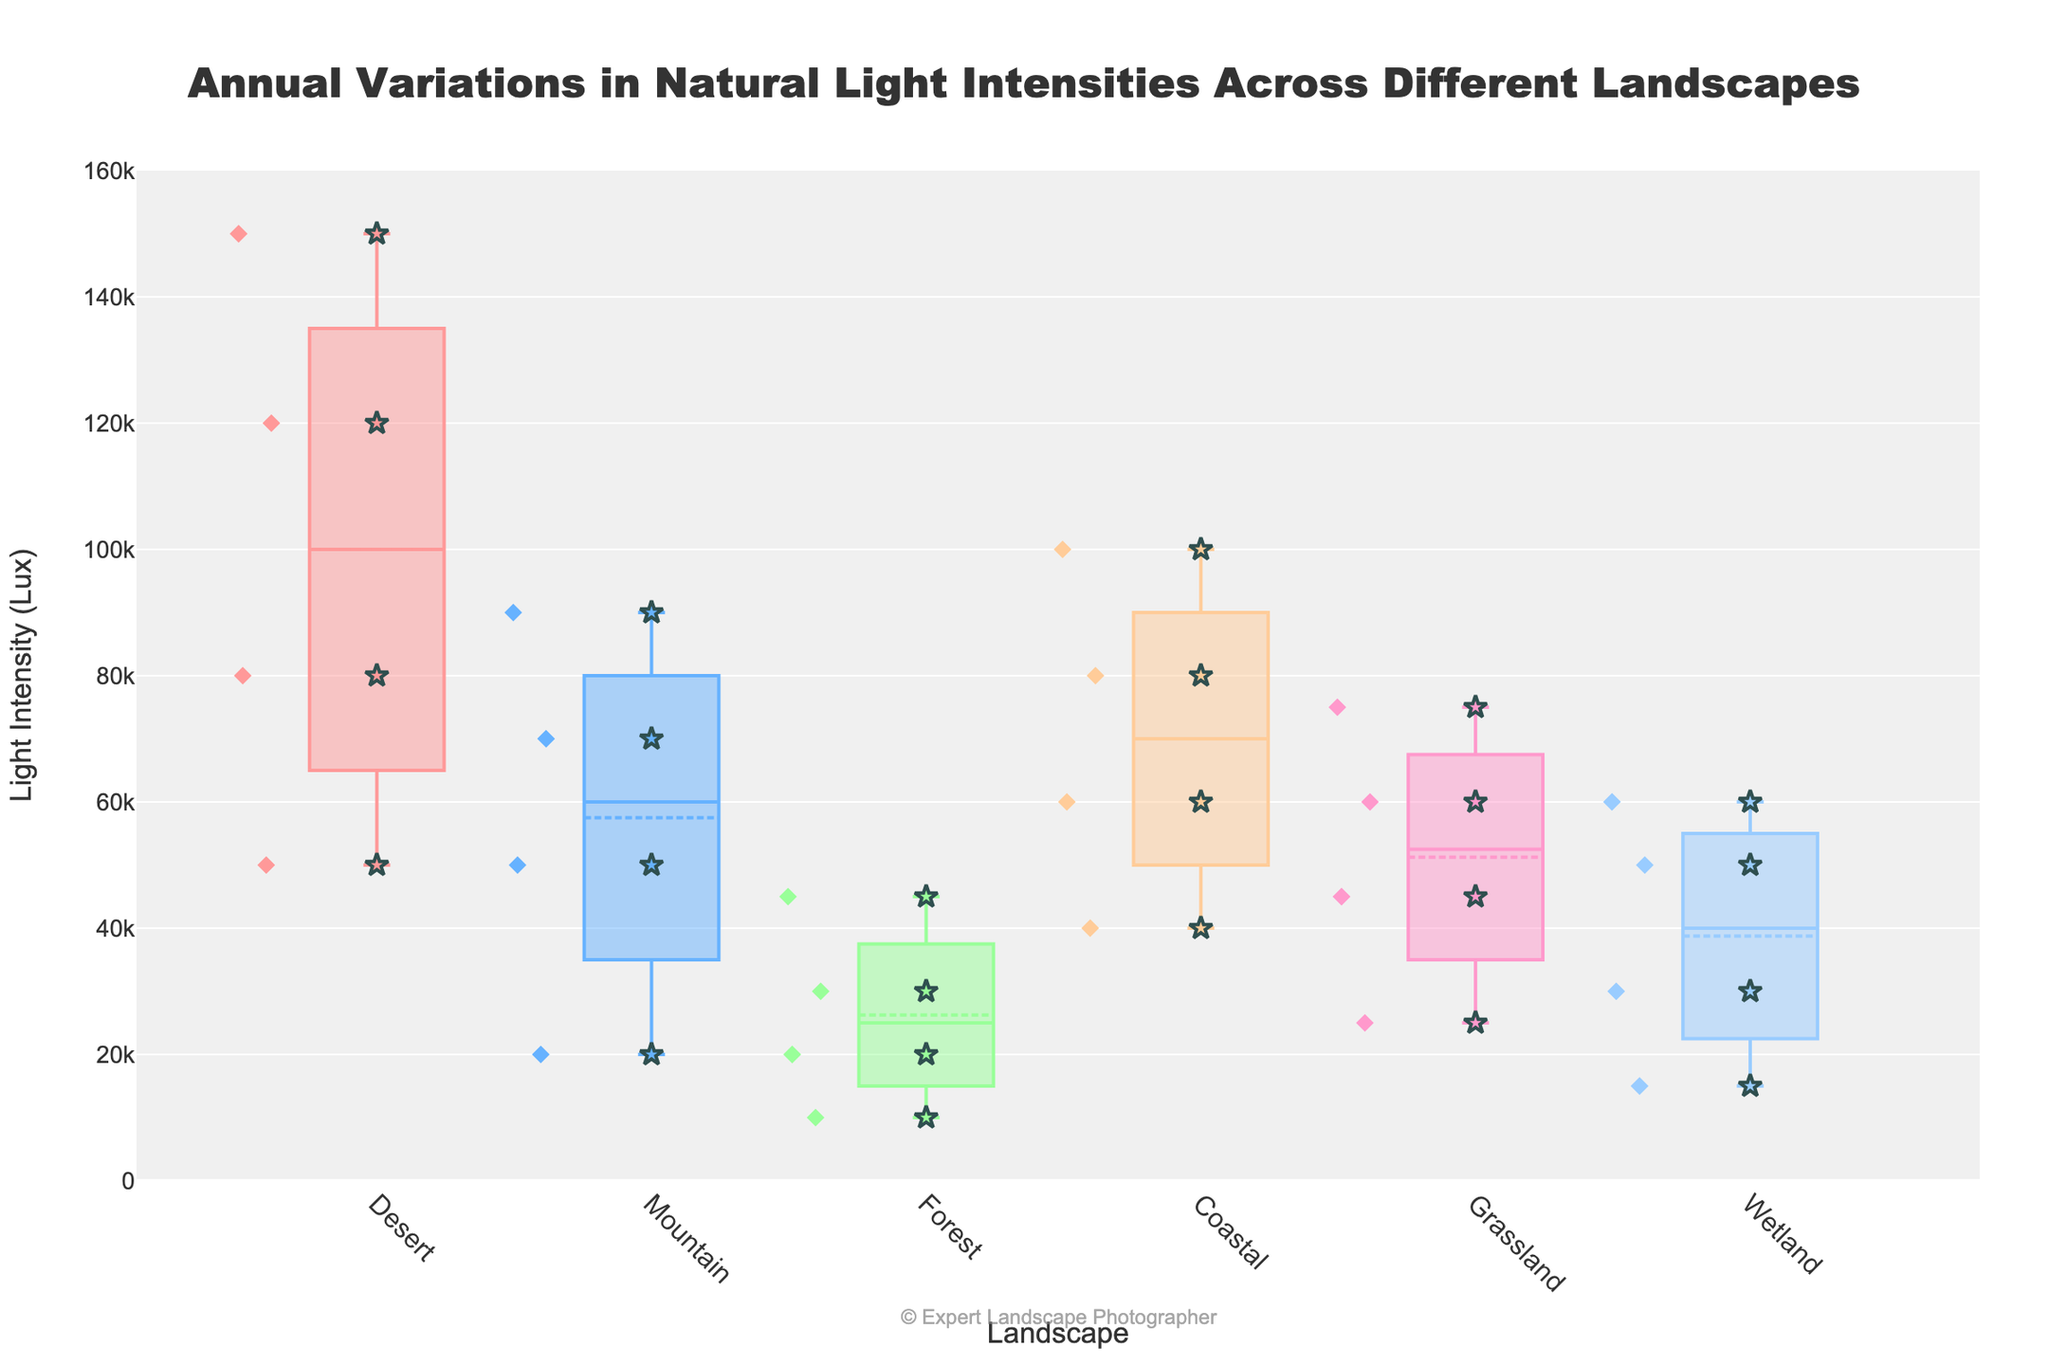What is the title of the figure? The title of the figure is usually found at the top center of the plot. Here, it is clearly labeled in larger font.
Answer: Annual Variations in Natural Light Intensities Across Different Landscapes What is the median light intensity in the Desert landscape? To find the median light intensity, locate the box plot for the Desert landscape. The median is represented by the line inside the box.
Answer: 85000 Which landscape has the highest maximum light intensity? To determine the landscape with the highest maximum light intensity, compare the top whiskers of all the box plots and identify which reaches the highest value on the y-axis.
Answer: Desert What is the range of light intensities in the Forest landscape during the Summer season? Look for the scatter point within the Forest landscape's box plot corresponding to the Summer season and find its y-axis value.
Answer: 45000 Which landscape experiences the lowest light intensity during Winter? Compare the lowest scatter points within the Winter season for each landscape, noting which one falls lowest on the y-axis.
Answer: Forest What color represents the Coastal landscape in the plot? Each landscape is represented by a different color for their box plot. Identify the Coastal landscape's box plot color by visually inspecting the figure.
Answer: Orange Compare the interquartile ranges (IQR) of the Mountain and Grassland landscapes. Which one is larger? For each landscape, the IQR is the distance between the top and bottom edges of the box (75th percentile and 25th percentile). Compare these distances for Mountain and Grassland landscapes.
Answer: Mountain Which landscape has the smallest variance in light intensities across all seasons? Variance can be visually approximated by the length of the whiskers and the spread of the scatter points. Identify the landscape with the smallest spread.
Answer: Forest How does the median light intensity in Coastal compare to Wetland across all seasons? Examine the median lines within the boxes for both Coastal and Wetland landscapes. Compare their positions on the y-axis to see which is higher.
Answer: Coastal has a higher median What symbols are used to represent the scatter points, and what is their significance? Scatter points for each landscape are represented by star symbols, which help to clearly distinguish individual data points within each box plot. These symbols highlight specific seasonal data by overlaying them as points of interest on top of the box plot distribution.
Answer: Stars 